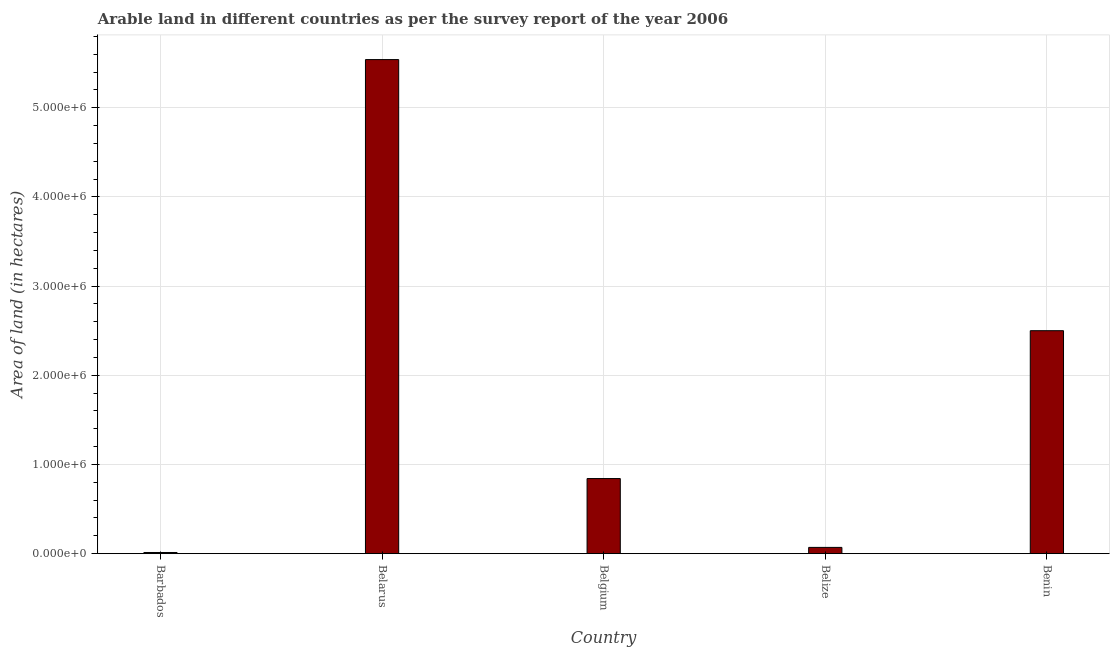What is the title of the graph?
Your answer should be very brief. Arable land in different countries as per the survey report of the year 2006. What is the label or title of the X-axis?
Offer a very short reply. Country. What is the label or title of the Y-axis?
Provide a short and direct response. Area of land (in hectares). What is the area of land in Benin?
Offer a terse response. 2.50e+06. Across all countries, what is the maximum area of land?
Your answer should be very brief. 5.54e+06. Across all countries, what is the minimum area of land?
Offer a very short reply. 1.30e+04. In which country was the area of land maximum?
Ensure brevity in your answer.  Belarus. In which country was the area of land minimum?
Offer a terse response. Barbados. What is the sum of the area of land?
Your answer should be compact. 8.96e+06. What is the difference between the area of land in Belarus and Benin?
Ensure brevity in your answer.  3.04e+06. What is the average area of land per country?
Provide a short and direct response. 1.79e+06. What is the median area of land?
Provide a succinct answer. 8.42e+05. What is the ratio of the area of land in Barbados to that in Belgium?
Offer a terse response. 0.01. Is the area of land in Belarus less than that in Belgium?
Offer a terse response. No. What is the difference between the highest and the second highest area of land?
Offer a very short reply. 3.04e+06. Is the sum of the area of land in Belize and Benin greater than the maximum area of land across all countries?
Ensure brevity in your answer.  No. What is the difference between the highest and the lowest area of land?
Ensure brevity in your answer.  5.53e+06. In how many countries, is the area of land greater than the average area of land taken over all countries?
Give a very brief answer. 2. Are all the bars in the graph horizontal?
Offer a very short reply. No. What is the Area of land (in hectares) in Barbados?
Provide a short and direct response. 1.30e+04. What is the Area of land (in hectares) of Belarus?
Offer a very short reply. 5.54e+06. What is the Area of land (in hectares) in Belgium?
Your answer should be compact. 8.42e+05. What is the Area of land (in hectares) of Belize?
Offer a very short reply. 7.00e+04. What is the Area of land (in hectares) in Benin?
Ensure brevity in your answer.  2.50e+06. What is the difference between the Area of land (in hectares) in Barbados and Belarus?
Your answer should be compact. -5.53e+06. What is the difference between the Area of land (in hectares) in Barbados and Belgium?
Provide a short and direct response. -8.29e+05. What is the difference between the Area of land (in hectares) in Barbados and Belize?
Make the answer very short. -5.70e+04. What is the difference between the Area of land (in hectares) in Barbados and Benin?
Your answer should be compact. -2.49e+06. What is the difference between the Area of land (in hectares) in Belarus and Belgium?
Give a very brief answer. 4.70e+06. What is the difference between the Area of land (in hectares) in Belarus and Belize?
Ensure brevity in your answer.  5.47e+06. What is the difference between the Area of land (in hectares) in Belarus and Benin?
Ensure brevity in your answer.  3.04e+06. What is the difference between the Area of land (in hectares) in Belgium and Belize?
Your answer should be very brief. 7.72e+05. What is the difference between the Area of land (in hectares) in Belgium and Benin?
Offer a terse response. -1.66e+06. What is the difference between the Area of land (in hectares) in Belize and Benin?
Your answer should be very brief. -2.43e+06. What is the ratio of the Area of land (in hectares) in Barbados to that in Belarus?
Your answer should be very brief. 0. What is the ratio of the Area of land (in hectares) in Barbados to that in Belgium?
Ensure brevity in your answer.  0.01. What is the ratio of the Area of land (in hectares) in Barbados to that in Belize?
Give a very brief answer. 0.19. What is the ratio of the Area of land (in hectares) in Barbados to that in Benin?
Provide a short and direct response. 0.01. What is the ratio of the Area of land (in hectares) in Belarus to that in Belgium?
Give a very brief answer. 6.58. What is the ratio of the Area of land (in hectares) in Belarus to that in Belize?
Your answer should be very brief. 79.14. What is the ratio of the Area of land (in hectares) in Belarus to that in Benin?
Make the answer very short. 2.22. What is the ratio of the Area of land (in hectares) in Belgium to that in Belize?
Offer a very short reply. 12.03. What is the ratio of the Area of land (in hectares) in Belgium to that in Benin?
Your response must be concise. 0.34. What is the ratio of the Area of land (in hectares) in Belize to that in Benin?
Your response must be concise. 0.03. 